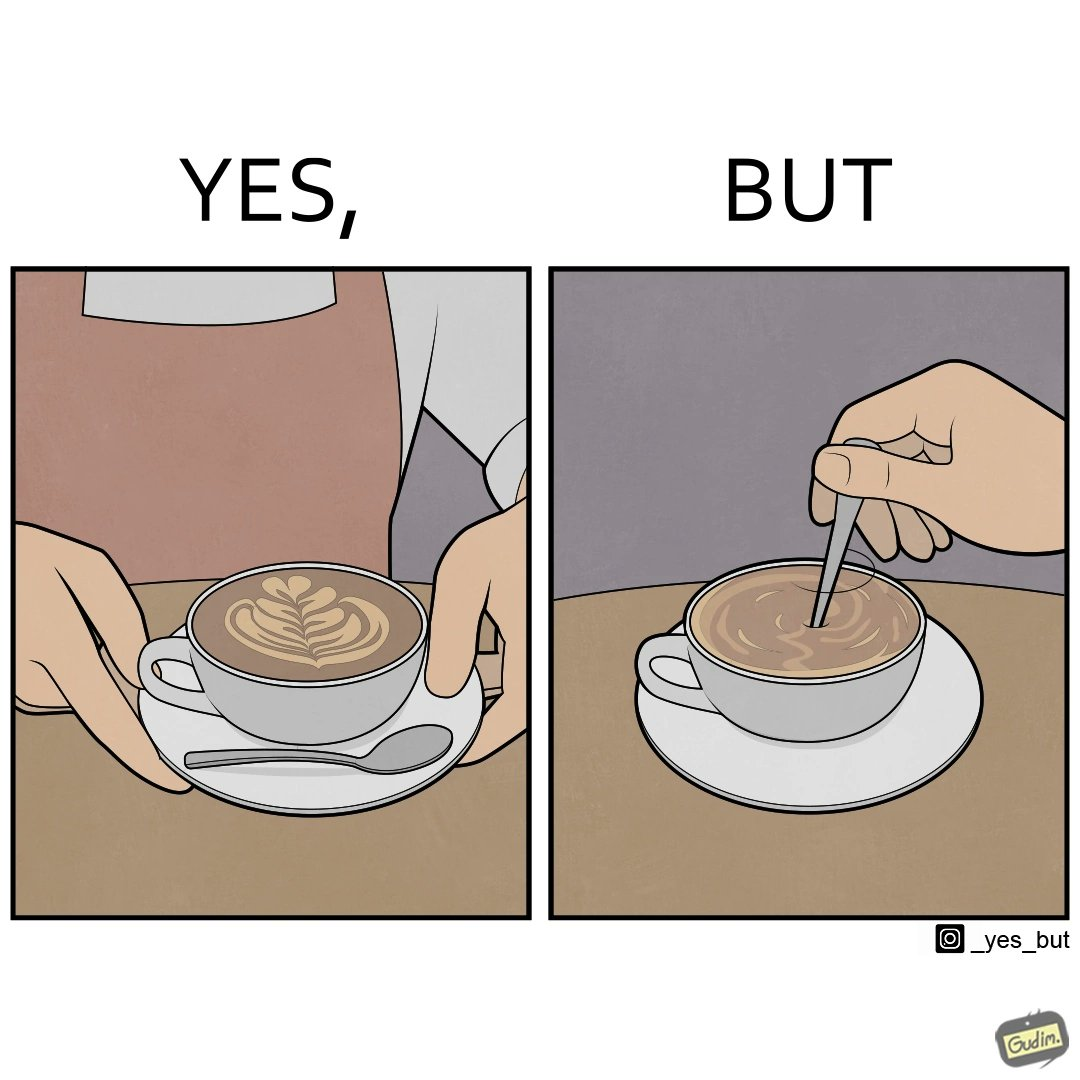What is shown in the left half versus the right half of this image? In the left part of the image: a cup of coffee with latte art on it In the right part of the image: a person stirring the coffee with spoon 